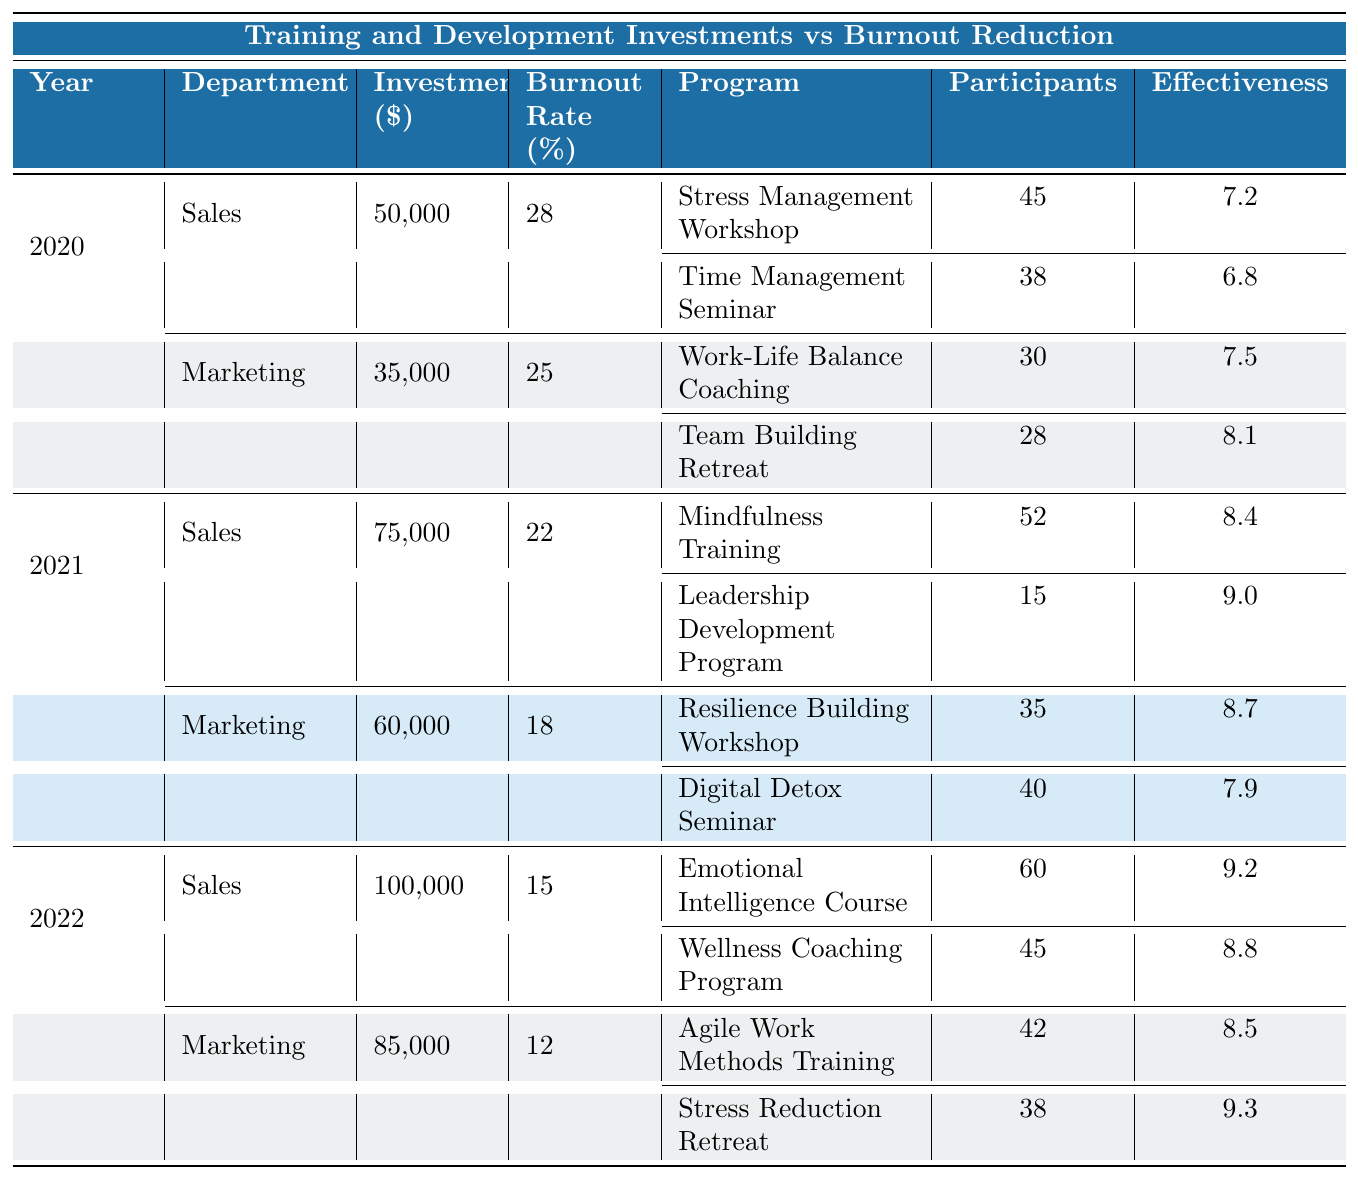What was the burnout rate in Sales in 2021? Looking at the table, in the year 2021, for the Sales department, the burnout rate is explicitly listed as 22%.
Answer: 22% Which department had the highest training investment in 2022? In 2022, the Sales department had a training investment of $100,000, which is higher than the Marketing department's investment of $85,000.
Answer: Sales What was the average effectiveness of the programs in Marketing for 2021? Adding up the effectiveness scores from the two Marketing programs in 2021: 8.7 + 7.9 = 16.6. Then dividing by the number of programs (2) gives an average effectiveness of 16.6 / 2 = 8.3.
Answer: 8.3 Did the burnout rate in Sales decrease from 2020 to 2022? Comparing the burnout rates, in 2020 it was 28%, and in 2022 it reduced to 15%, confirming a decrease over the two years.
Answer: Yes What is the total investment for Marketing across all three years? To find the total investment for Marketing, add the investments for each year: $35,000 (2020) + $60,000 (2021) + $85,000 (2022) = $180,000.
Answer: $180,000 Which program in Sales had the highest effectiveness in 2022? In 2022, the Emotional Intelligence Course in Sales had an effectiveness score of 9.2, which is higher than the Wellness Coaching Program's score of 8.8.
Answer: Emotional Intelligence Course What was the change in the burnout rate for Marketing from 2020 to 2022? The burnout rate in Marketing was 25% in 2020 and dropped to 12% in 2022. Calculating the change gives 25% - 12% = 13%, indicating a significant drop in burnout rate.
Answer: 13% Did the average number of participants in Sales programs increase from 2020 to 2021? In 2020, Sales had 45 participants in the Stress Management Workshop and 38 in the Time Management Seminar, giving a total of 83 participants across both programs. In 2021, there were 52 in Mindfulness Training and 15 in Leadership Development, totaling 67 participants. The average decreased from 83/2 = 41.5 in 2020 to 67/2 = 33.5 in 2021.
Answer: No What is the effectiveness of the program with the lowest participant count in Marketing for 2020? The program with the lowest participant count in Marketing for 2020 is the Team Building Retreat with 28 participants. Its effectiveness score is 8.1.
Answer: 8.1 If we sum the total effectiveness of all programs in Sales for 2021, what value do we get? Adding the effectiveness of both Sales programs in 2021: 8.4 (Mindfulness Training) + 9.0 (Leadership Development Program) equals a total effectiveness of 17.4.
Answer: 17.4 